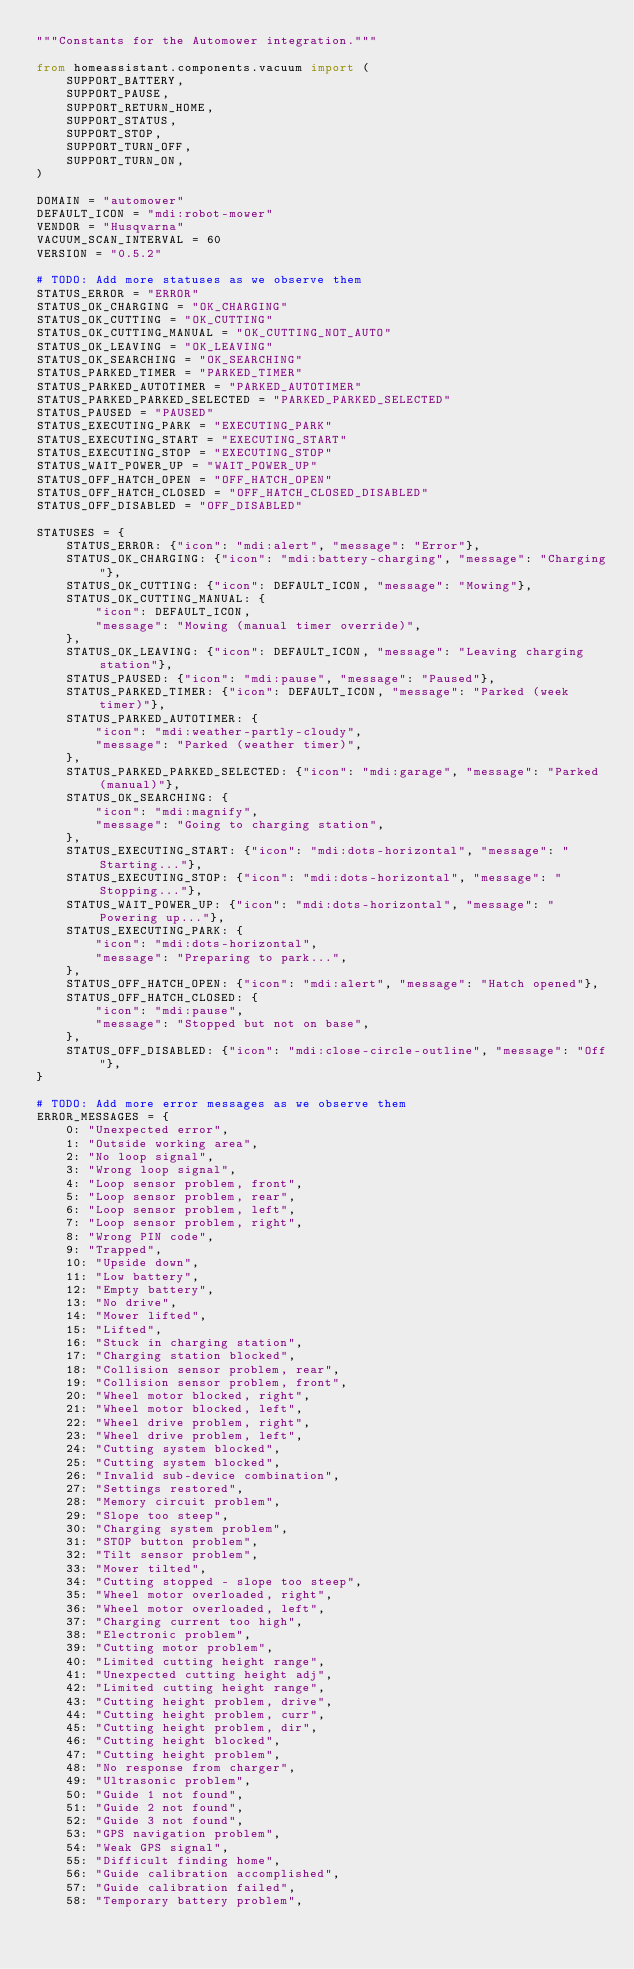<code> <loc_0><loc_0><loc_500><loc_500><_Python_>"""Constants for the Automower integration."""

from homeassistant.components.vacuum import (
    SUPPORT_BATTERY,
    SUPPORT_PAUSE,
    SUPPORT_RETURN_HOME,
    SUPPORT_STATUS,
    SUPPORT_STOP,
    SUPPORT_TURN_OFF,
    SUPPORT_TURN_ON,
)

DOMAIN = "automower"
DEFAULT_ICON = "mdi:robot-mower"
VENDOR = "Husqvarna"
VACUUM_SCAN_INTERVAL = 60
VERSION = "0.5.2"

# TODO: Add more statuses as we observe them
STATUS_ERROR = "ERROR"
STATUS_OK_CHARGING = "OK_CHARGING"
STATUS_OK_CUTTING = "OK_CUTTING"
STATUS_OK_CUTTING_MANUAL = "OK_CUTTING_NOT_AUTO"
STATUS_OK_LEAVING = "OK_LEAVING"
STATUS_OK_SEARCHING = "OK_SEARCHING"
STATUS_PARKED_TIMER = "PARKED_TIMER"
STATUS_PARKED_AUTOTIMER = "PARKED_AUTOTIMER"
STATUS_PARKED_PARKED_SELECTED = "PARKED_PARKED_SELECTED"
STATUS_PAUSED = "PAUSED"
STATUS_EXECUTING_PARK = "EXECUTING_PARK"
STATUS_EXECUTING_START = "EXECUTING_START"
STATUS_EXECUTING_STOP = "EXECUTING_STOP"
STATUS_WAIT_POWER_UP = "WAIT_POWER_UP"
STATUS_OFF_HATCH_OPEN = "OFF_HATCH_OPEN"
STATUS_OFF_HATCH_CLOSED = "OFF_HATCH_CLOSED_DISABLED"
STATUS_OFF_DISABLED = "OFF_DISABLED"

STATUSES = {
    STATUS_ERROR: {"icon": "mdi:alert", "message": "Error"},
    STATUS_OK_CHARGING: {"icon": "mdi:battery-charging", "message": "Charging"},
    STATUS_OK_CUTTING: {"icon": DEFAULT_ICON, "message": "Mowing"},
    STATUS_OK_CUTTING_MANUAL: {
        "icon": DEFAULT_ICON,
        "message": "Mowing (manual timer override)",
    },
    STATUS_OK_LEAVING: {"icon": DEFAULT_ICON, "message": "Leaving charging station"},
    STATUS_PAUSED: {"icon": "mdi:pause", "message": "Paused"},
    STATUS_PARKED_TIMER: {"icon": DEFAULT_ICON, "message": "Parked (week timer)"},
    STATUS_PARKED_AUTOTIMER: {
        "icon": "mdi:weather-partly-cloudy",
        "message": "Parked (weather timer)",
    },
    STATUS_PARKED_PARKED_SELECTED: {"icon": "mdi:garage", "message": "Parked (manual)"},
    STATUS_OK_SEARCHING: {
        "icon": "mdi:magnify",
        "message": "Going to charging station",
    },
    STATUS_EXECUTING_START: {"icon": "mdi:dots-horizontal", "message": "Starting..."},
    STATUS_EXECUTING_STOP: {"icon": "mdi:dots-horizontal", "message": "Stopping..."},
    STATUS_WAIT_POWER_UP: {"icon": "mdi:dots-horizontal", "message": "Powering up..."},
    STATUS_EXECUTING_PARK: {
        "icon": "mdi:dots-horizontal",
        "message": "Preparing to park...",
    },
    STATUS_OFF_HATCH_OPEN: {"icon": "mdi:alert", "message": "Hatch opened"},
    STATUS_OFF_HATCH_CLOSED: {
        "icon": "mdi:pause",
        "message": "Stopped but not on base",
    },
    STATUS_OFF_DISABLED: {"icon": "mdi:close-circle-outline", "message": "Off"},
}

# TODO: Add more error messages as we observe them
ERROR_MESSAGES = {
    0: "Unexpected error",
    1: "Outside working area",
    2: "No loop signal",
    3: "Wrong loop signal",
    4: "Loop sensor problem, front",
    5: "Loop sensor problem, rear",
    6: "Loop sensor problem, left",
    7: "Loop sensor problem, right",
    8: "Wrong PIN code",
    9: "Trapped",
    10: "Upside down",
    11: "Low battery",
    12: "Empty battery",
    13: "No drive",
    14: "Mower lifted",
    15: "Lifted",
    16: "Stuck in charging station",
    17: "Charging station blocked",
    18: "Collision sensor problem, rear",
    19: "Collision sensor problem, front",
    20: "Wheel motor blocked, right",
    21: "Wheel motor blocked, left",
    22: "Wheel drive problem, right",
    23: "Wheel drive problem, left",
    24: "Cutting system blocked",
    25: "Cutting system blocked",
    26: "Invalid sub-device combination",
    27: "Settings restored",
    28: "Memory circuit problem",
    29: "Slope too steep",
    30: "Charging system problem",
    31: "STOP button problem",
    32: "Tilt sensor problem",
    33: "Mower tilted",
    34: "Cutting stopped - slope too steep",
    35: "Wheel motor overloaded, right",
    36: "Wheel motor overloaded, left",
    37: "Charging current too high",
    38: "Electronic problem",
    39: "Cutting motor problem",
    40: "Limited cutting height range",
    41: "Unexpected cutting height adj",
    42: "Limited cutting height range",
    43: "Cutting height problem, drive",
    44: "Cutting height problem, curr",
    45: "Cutting height problem, dir",
    46: "Cutting height blocked",
    47: "Cutting height problem",
    48: "No response from charger",
    49: "Ultrasonic problem",
    50: "Guide 1 not found",
    51: "Guide 2 not found",
    52: "Guide 3 not found",
    53: "GPS navigation problem",
    54: "Weak GPS signal",
    55: "Difficult finding home",
    56: "Guide calibration accomplished",
    57: "Guide calibration failed",
    58: "Temporary battery problem",</code> 